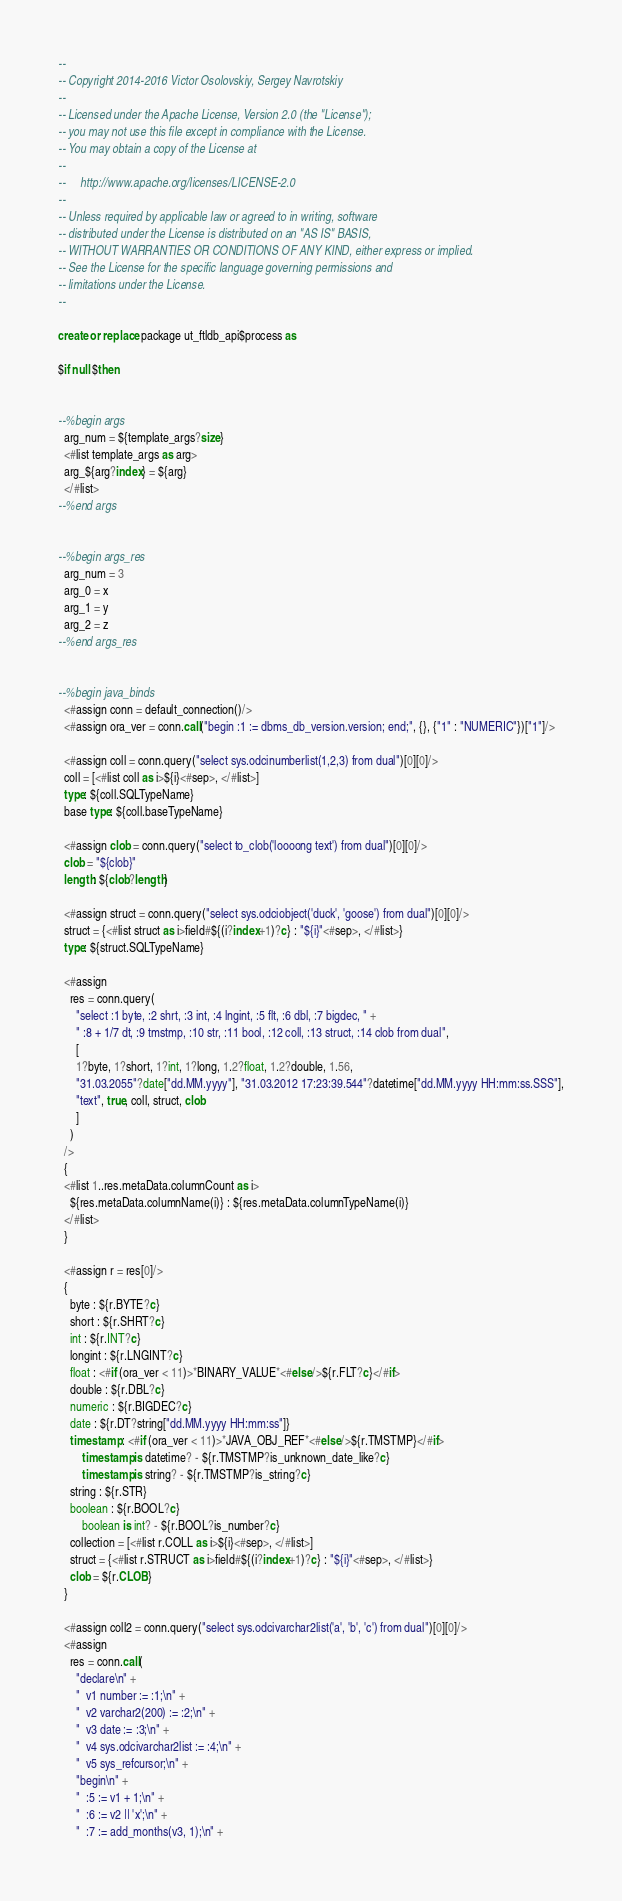Convert code to text. <code><loc_0><loc_0><loc_500><loc_500><_SQL_>--
-- Copyright 2014-2016 Victor Osolovskiy, Sergey Navrotskiy
--
-- Licensed under the Apache License, Version 2.0 (the "License");
-- you may not use this file except in compliance with the License.
-- You may obtain a copy of the License at
--
--     http://www.apache.org/licenses/LICENSE-2.0
--
-- Unless required by applicable law or agreed to in writing, software
-- distributed under the License is distributed on an "AS IS" BASIS,
-- WITHOUT WARRANTIES OR CONDITIONS OF ANY KIND, either express or implied.
-- See the License for the specific language governing permissions and
-- limitations under the License.
--

create or replace package ut_ftldb_api$process as

$if null $then


--%begin args
  arg_num = ${template_args?size}
  <#list template_args as arg>
  arg_${arg?index} = ${arg}
  </#list>
--%end args


--%begin args_res
  arg_num = 3
  arg_0 = x
  arg_1 = y
  arg_2 = z
--%end args_res


--%begin java_binds
  <#assign conn = default_connection()/>
  <#assign ora_ver = conn.call("begin :1 := dbms_db_version.version; end;", {}, {"1" : "NUMERIC"})["1"]/>

  <#assign coll = conn.query("select sys.odcinumberlist(1,2,3) from dual")[0][0]/>
  coll = [<#list coll as i>${i}<#sep>, </#list>]
  type: ${coll.SQLTypeName}
  base type: ${coll.baseTypeName}

  <#assign clob = conn.query("select to_clob('loooong text') from dual")[0][0]/>
  clob = "${clob}"
  length: ${clob?length}

  <#assign struct = conn.query("select sys.odciobject('duck', 'goose') from dual")[0][0]/>
  struct = {<#list struct as i>field#${(i?index+1)?c} : "${i}"<#sep>, </#list>}
  type: ${struct.SQLTypeName}

  <#assign
    res = conn.query(
      "select :1 byte, :2 shrt, :3 int, :4 lngint, :5 flt, :6 dbl, :7 bigdec, " +
      " :8 + 1/7 dt, :9 tmstmp, :10 str, :11 bool, :12 coll, :13 struct, :14 clob from dual",
      [
      1?byte, 1?short, 1?int, 1?long, 1.2?float, 1.2?double, 1.56,
      "31.03.2055"?date["dd.MM.yyyy"], "31.03.2012 17:23:39.544"?datetime["dd.MM.yyyy HH:mm:ss.SSS"],
      "text", true, coll, struct, clob
      ]
    )
  />
  {
  <#list 1..res.metaData.columnCount as i>
    ${res.metaData.columnName(i)} : ${res.metaData.columnTypeName(i)}
  </#list>
  }

  <#assign r = res[0]/>
  {
    byte : ${r.BYTE?c}
    short : ${r.SHRT?c}
    int : ${r.INT?c}
    longint : ${r.LNGINT?c}
    float : <#if (ora_ver < 11)>*BINARY_VALUE*<#else/>${r.FLT?c}</#if>
    double : ${r.DBL?c}
    numeric : ${r.BIGDEC?c}
    date : ${r.DT?string["dd.MM.yyyy HH:mm:ss"]}
    timestamp : <#if (ora_ver < 11)>*JAVA_OBJ_REF*<#else/>${r.TMSTMP}</#if>
        timestamp is datetime? - ${r.TMSTMP?is_unknown_date_like?c}
        timestamp is string? - ${r.TMSTMP?is_string?c}
    string : ${r.STR}
    boolean : ${r.BOOL?c}
        boolean is int? - ${r.BOOL?is_number?c}
    collection = [<#list r.COLL as i>${i}<#sep>, </#list>]
    struct = {<#list r.STRUCT as i>field#${(i?index+1)?c} : "${i}"<#sep>, </#list>}
    clob = ${r.CLOB}
  }

  <#assign coll2 = conn.query("select sys.odcivarchar2list('a', 'b', 'c') from dual")[0][0]/>
  <#assign
    res = conn.call(
      "declare\n" +
      "  v1 number := :1;\n" +
      "  v2 varchar2(200) := :2;\n" +
      "  v3 date := :3;\n" +
      "  v4 sys.odcivarchar2list := :4;\n" +
      "  v5 sys_refcursor;\n" +
      "begin\n" +
      "  :5 := v1 + 1;\n" +
      "  :6 := v2 || 'x';\n" +
      "  :7 := add_months(v3, 1);\n" +</code> 